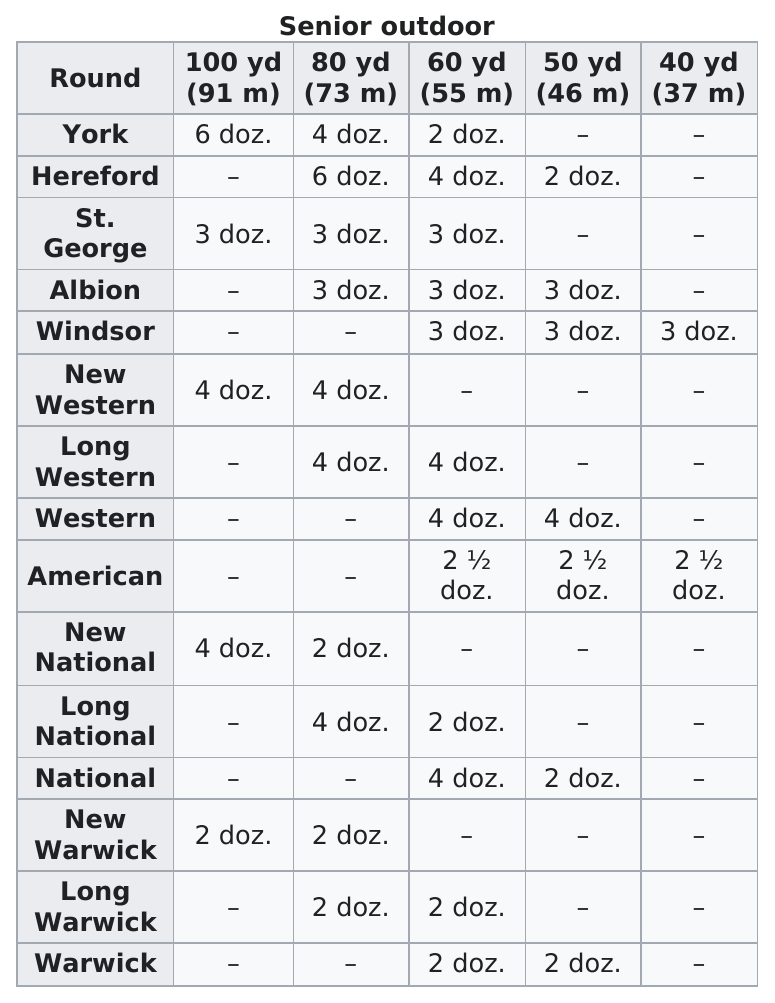Identify some key points in this picture. I, [Name], took two shots from a distance of 80 yards in the new national round. The first was a name and the second was a number shot. At 91 meters, York shot the most. At the top of the chart is York. At 100 yards, York shot 6 dozen. In the category of shooting more dozens at 100 yards than New Western, the York shoots the most dozens. 